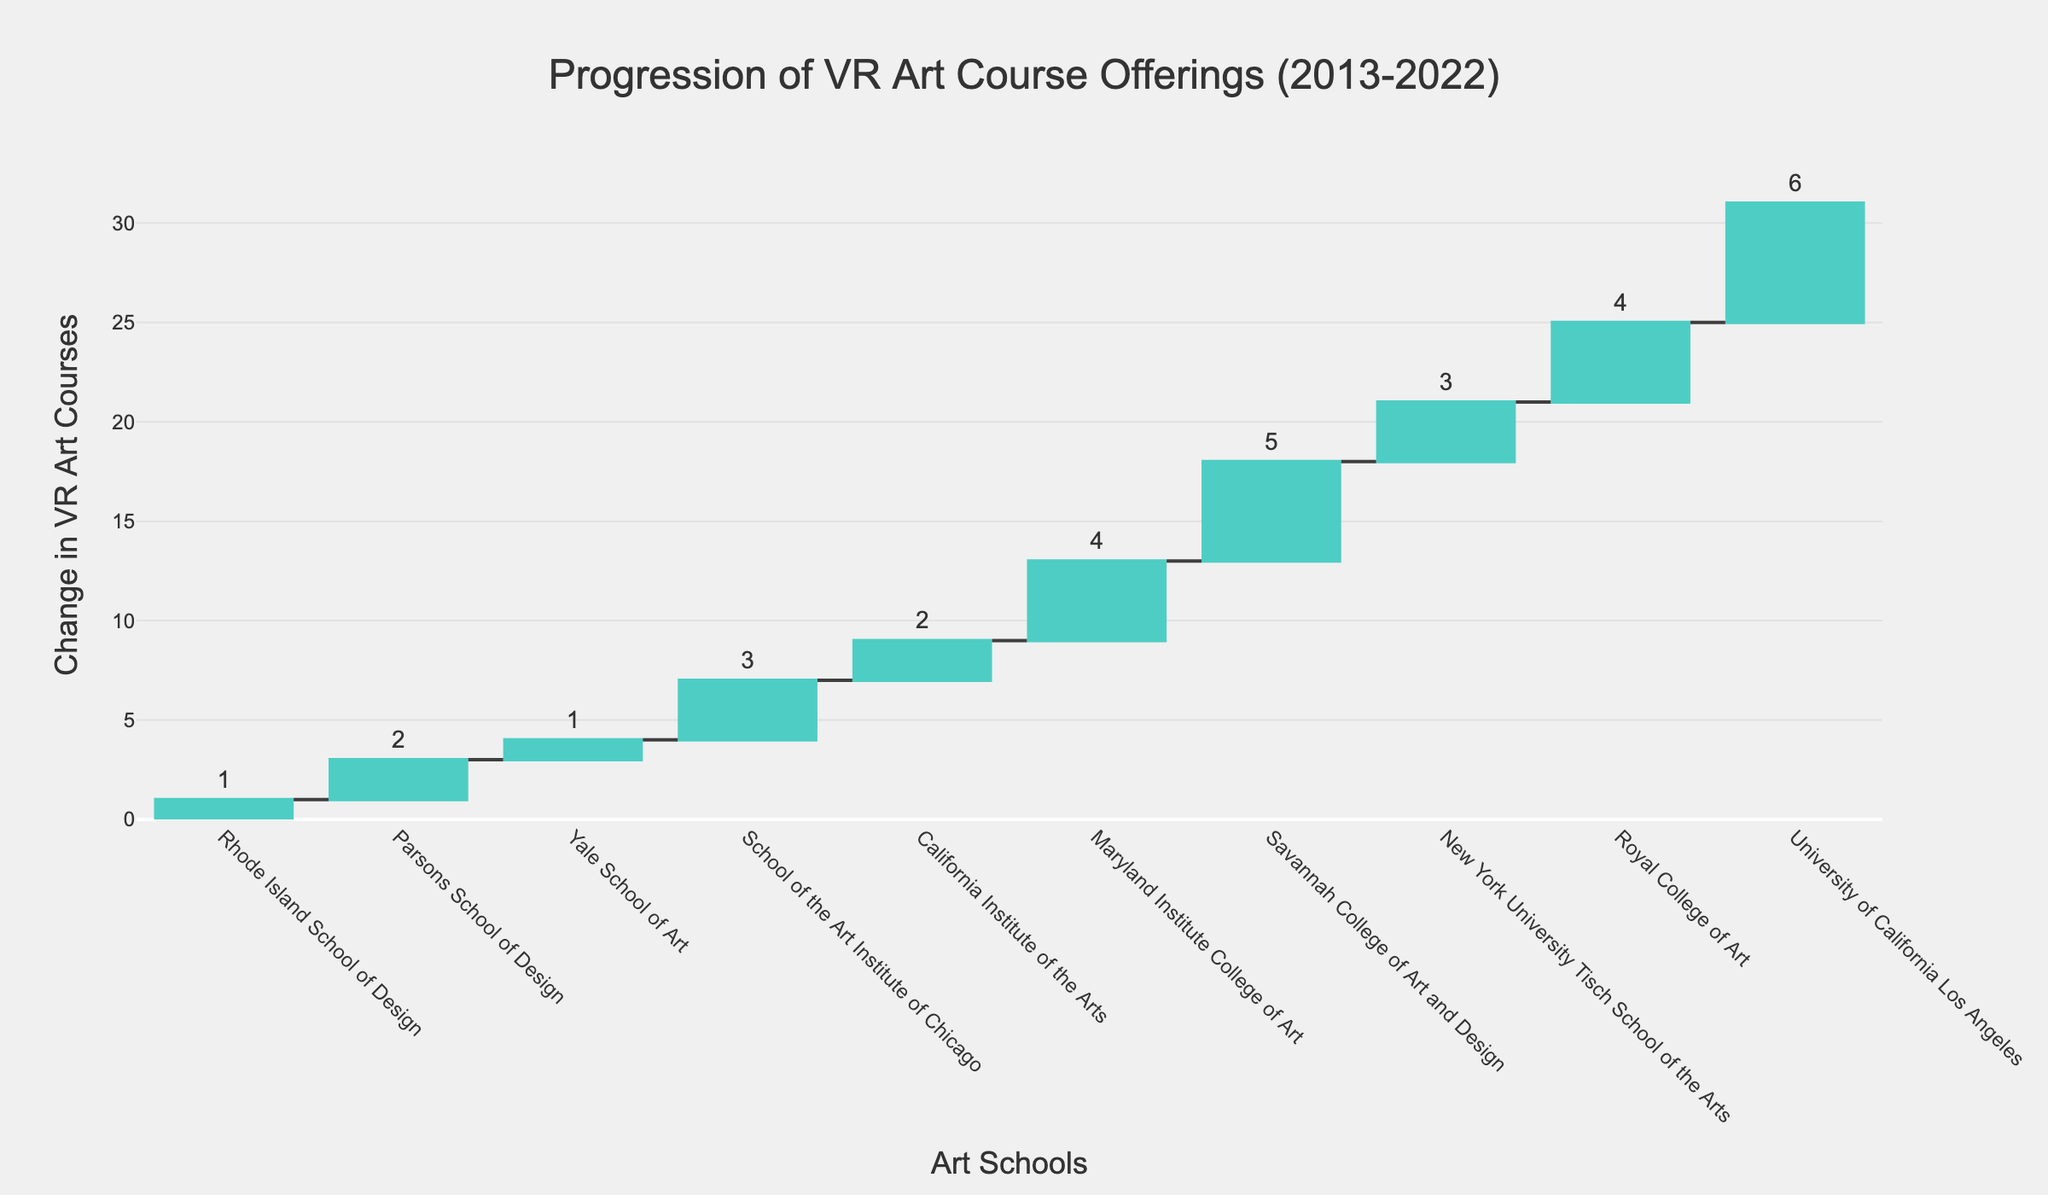What is the title of the figure? The title of the figure is usually prominently displayed at the top. In the generated plot, the title is "Progression of VR Art Course Offerings (2013-2022)" as specified in the layout settings.
Answer: Progression of VR Art Course Offerings (2013-2022) How many schools are represented in the figure? By counting the distinct schools labeled on the x-axis, we see 10 different art schools listed.
Answer: 10 Which school added the most VR art courses in a single year? By looking at the highest individual bar, which reaches the highest y-value, it is evident that the University of California Los Angeles added the most with 6 courses in 2022.
Answer: University of California Los Angeles What was the total change in VR art courses over the decade? To calculate the total change, sum up all the individual changes for each year from the data: 1 + 2 + 1 + 3 + 2 + 4 + 5 + 3 + 4 + 6. This equals 31.
Answer: 31 How many more VR art courses were added by Savannah College of Art and Design compared to Yale School of Art? Savannah College of Art and Design added 5 VR art courses while Yale School of Art added 1. Subtracting these two amounts, 5 - 1 equals 4.
Answer: 4 Which year had the highest addition of VR art courses and by which school? By examining the tallest individual bar, the year is 2022 and the school is University of California Los Angeles, which added 6 courses.
Answer: 2022, University of California Los Angeles Between 2016 and 2018, what was the combined change in VR art courses offered by the represented schools? Adding the changes from 2016, 2017, and 2018: 3 (School of the Art Institute of Chicago) + 2 (California Institute of the Arts) + 4 (Maryland Institute College of Art) equals 9.
Answer: 9 Which two schools had the smallest increase in VR course offerings and what were their respective changes? By identifying the shortest bars, we find that both Rhode Island School of Design and Yale School of Art had the smallest increases, each adding 1 course.
Answer: Rhode Island School of Design and Yale School of Art; 1 each What is the cumulative total of VR art courses added up to the year 2020? The cumulative total is obtained by summing the changes up to 2020: 1 (2013) + 2 (2014) + 1 (2015) + 3 (2016) + 2 (2017) + 4 (2018) + 5 (2019) + 3 (2020). This results in 21.
Answer: 21 